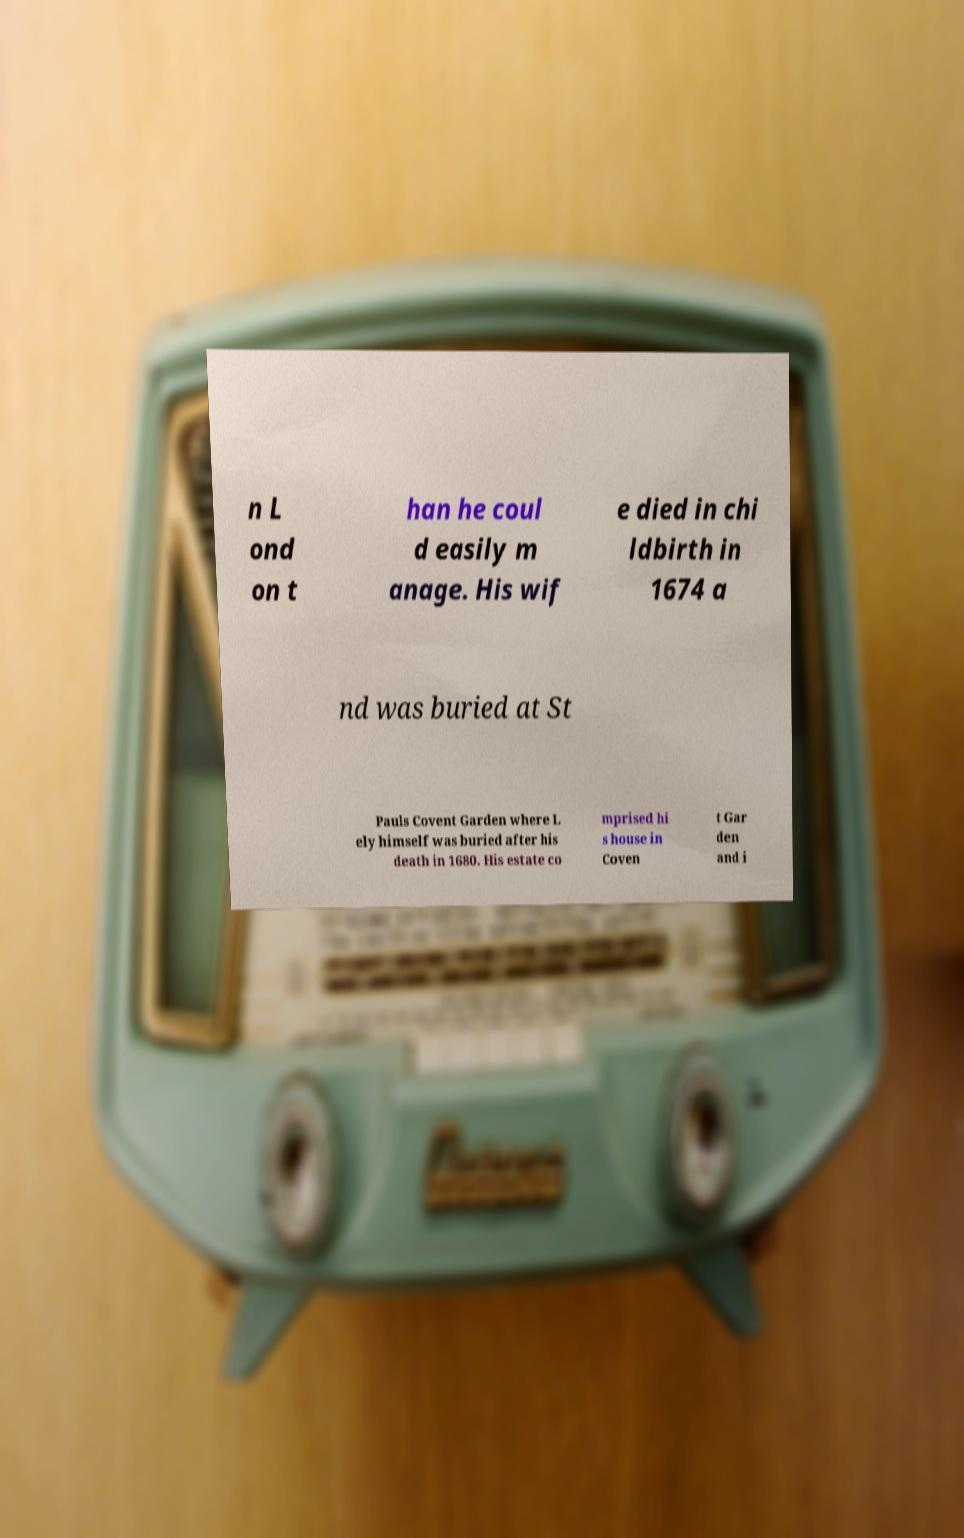For documentation purposes, I need the text within this image transcribed. Could you provide that? n L ond on t han he coul d easily m anage. His wif e died in chi ldbirth in 1674 a nd was buried at St Pauls Covent Garden where L ely himself was buried after his death in 1680. His estate co mprised hi s house in Coven t Gar den and i 